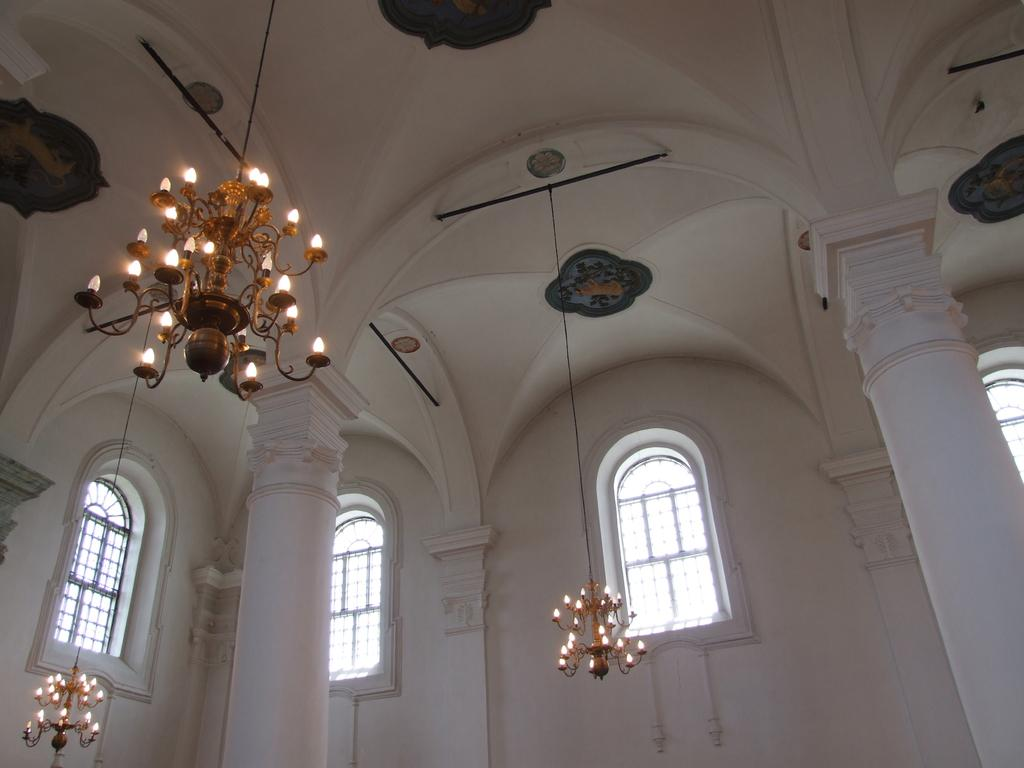What type of location is depicted in the image? The image shows the interior of a building. What architectural feature can be seen in the building? There are two pillars in the building. What lighting source is present in the image? There are lamps visible in the image. How can natural light enter the building? The building has many windows, allowing natural light to enter. What type of lace can be seen hanging from the ceiling in the image? There is no lace present in the image; it depicts the interior of a building with pillars, lamps, and windows. Can you see a horse inside the building in the image? There is no horse visible in the image; it shows the interior of a building with architectural features and lighting sources. 